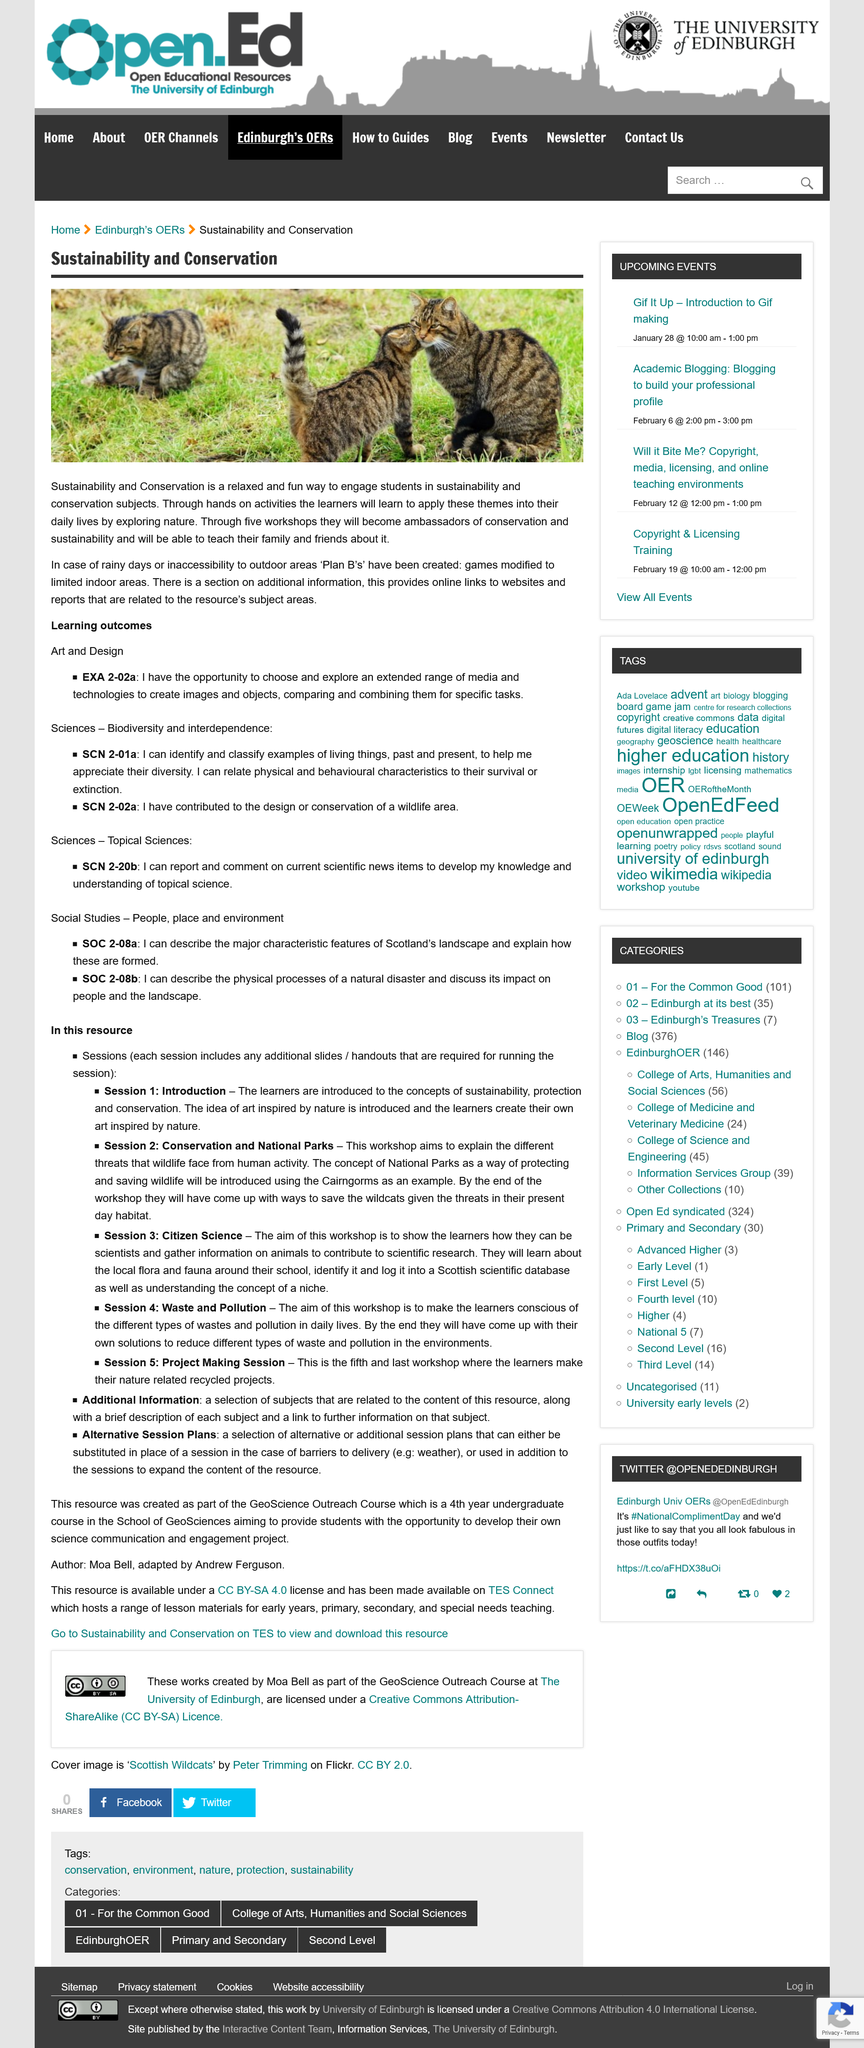Specify some key components in this picture. In the event of a decline in sustainability and conservation efforts due to adverse weather conditions, it is crucial to have alternative plans in place, such as modifying games to fit within limited indoor areas. One learning outcome applies to Art and Design. The resource contains supplementary information and alternative session plans. It is expected that the learners will engage in hands-on activities during the training. Session 4 focuses on the topics of waste and pollution, covering various aspects and solutions to mitigate their impact on the environment. 